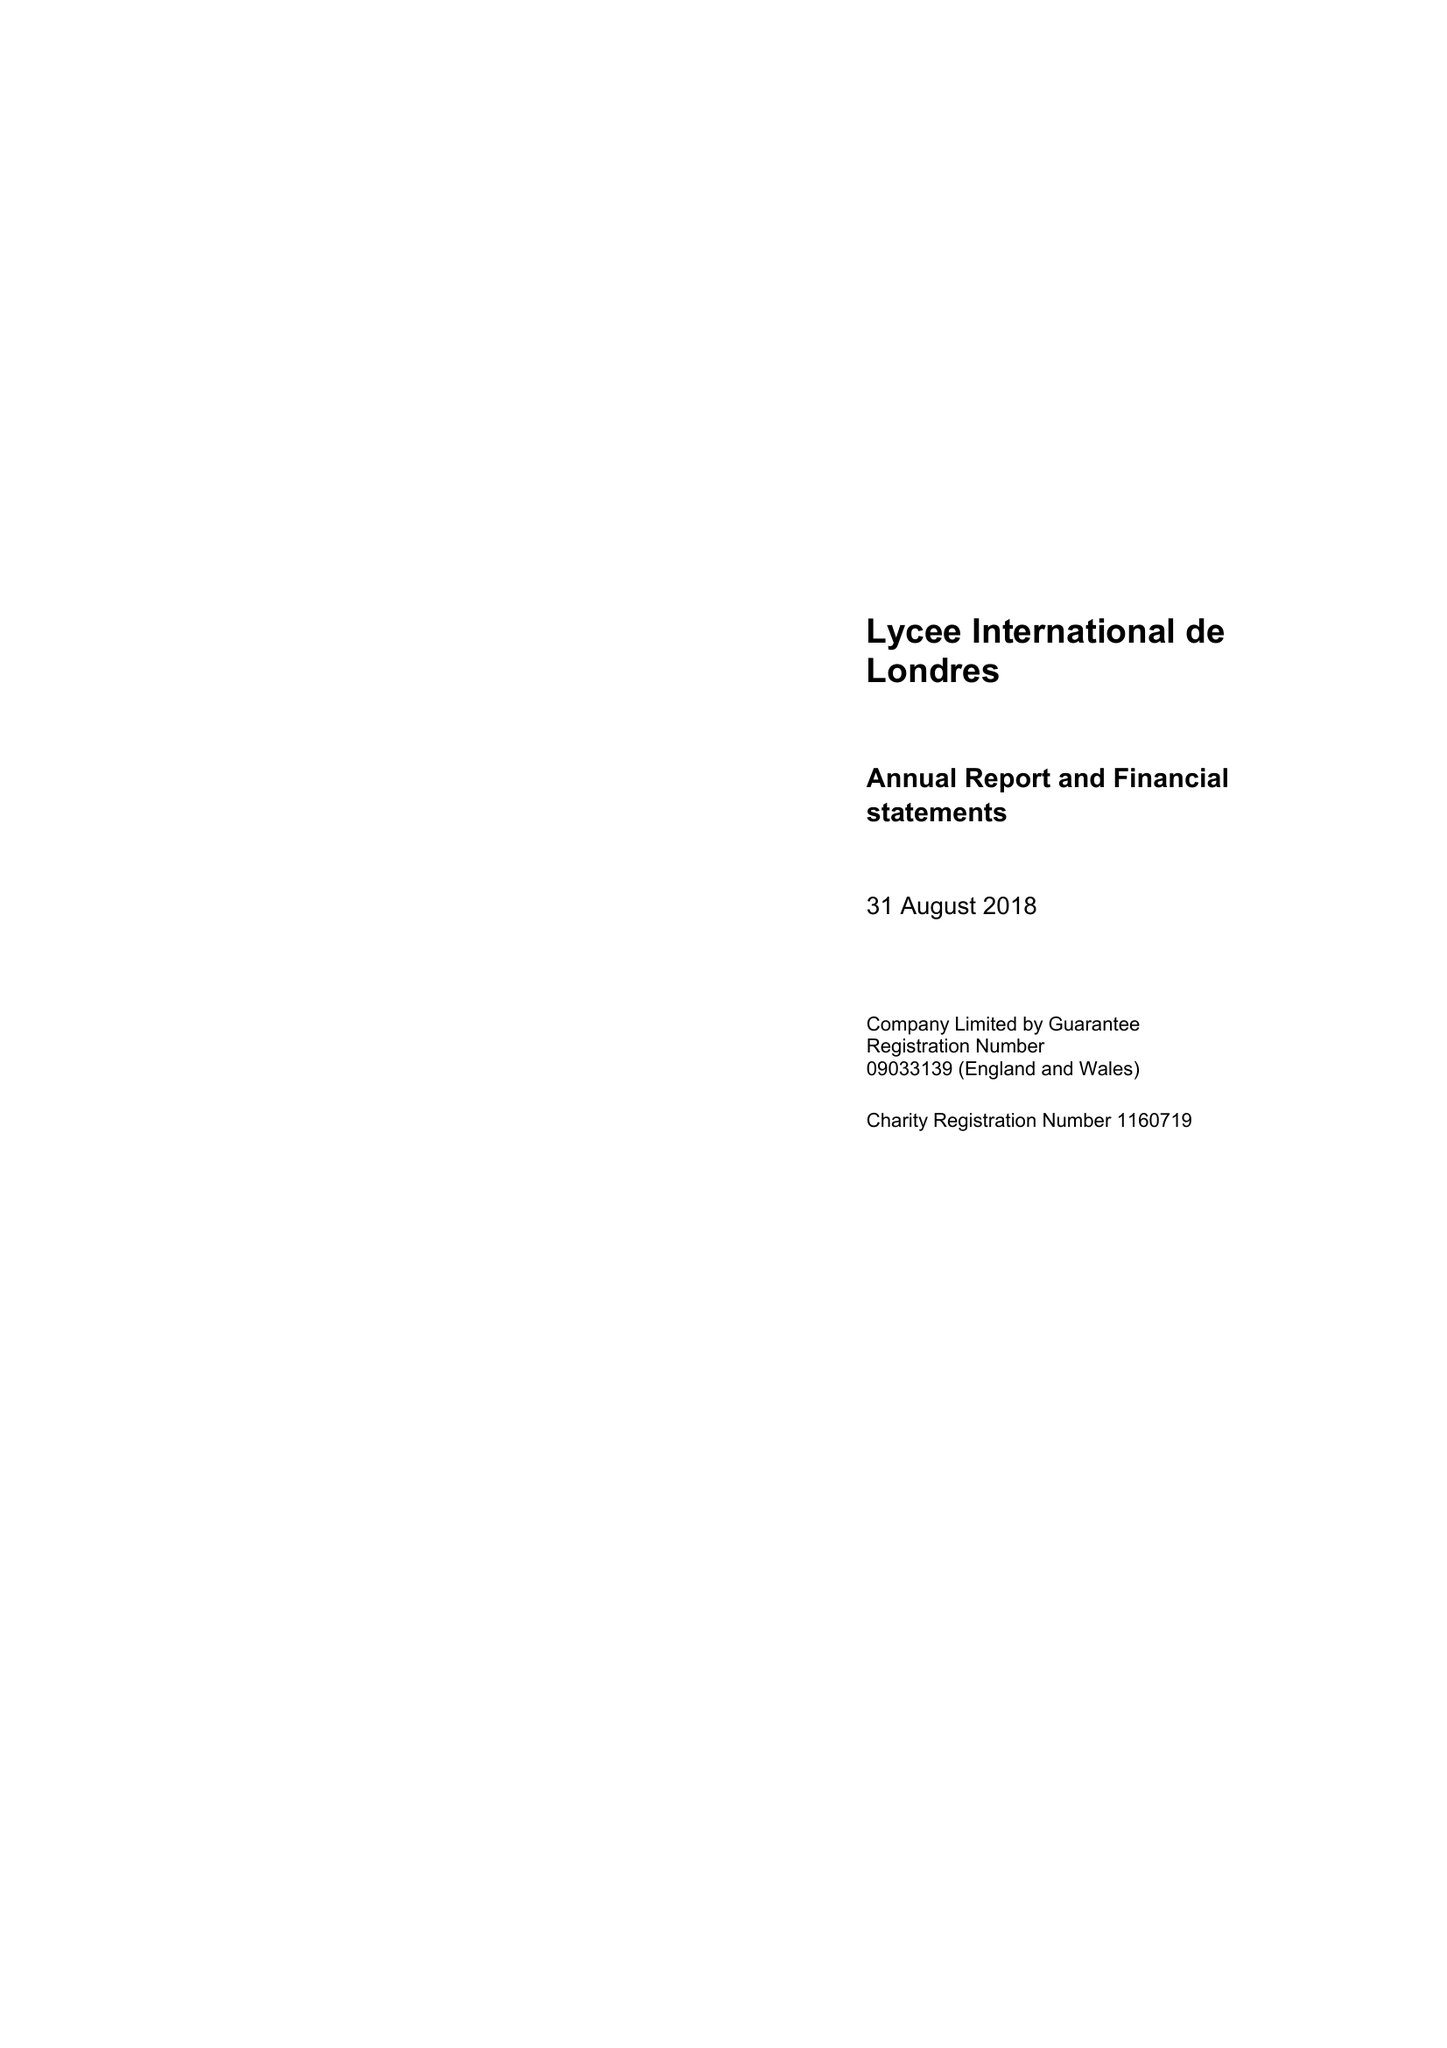What is the value for the address__post_town?
Answer the question using a single word or phrase. WEMBLEY 